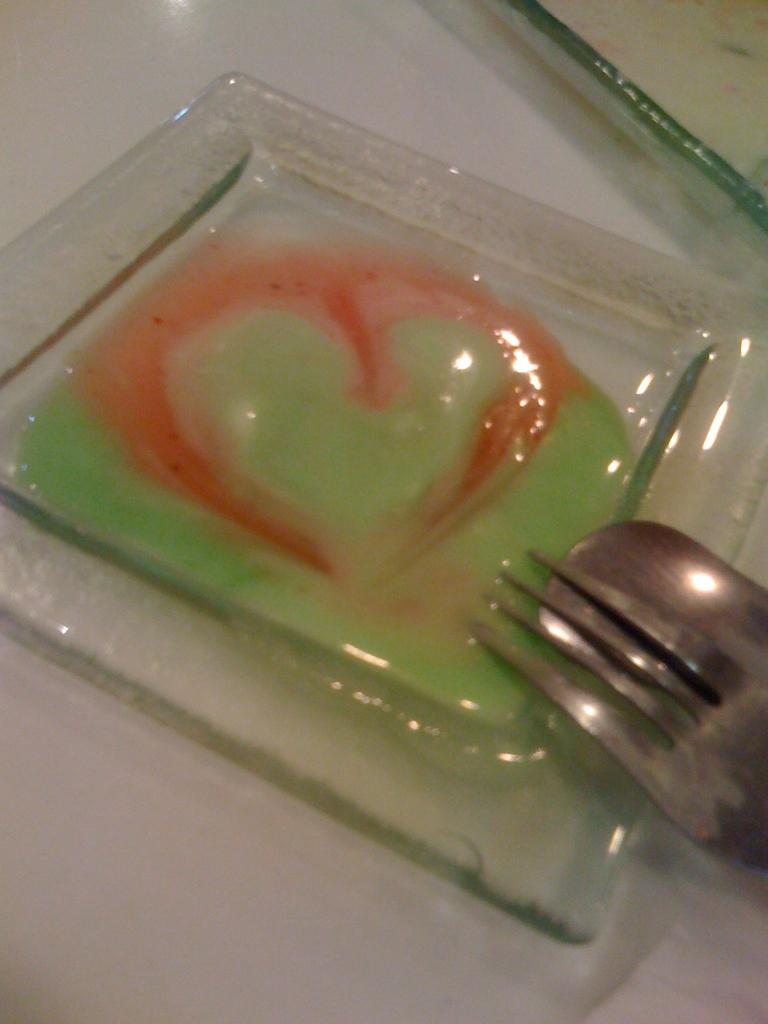What is the color of the surface in the image? The surface in the image is white. What object is placed on the white surface? There is a square-shaped glass plate on the surface. What is inside the glass plate? The glass plate contains red and green sauce. What utensils are visible near the glass plate? A part of a fork and a part of a spoon are visible near the glass plate. What type of beast is celebrating its birthday in the image? There is no beast or birthday celebration present in the image. 